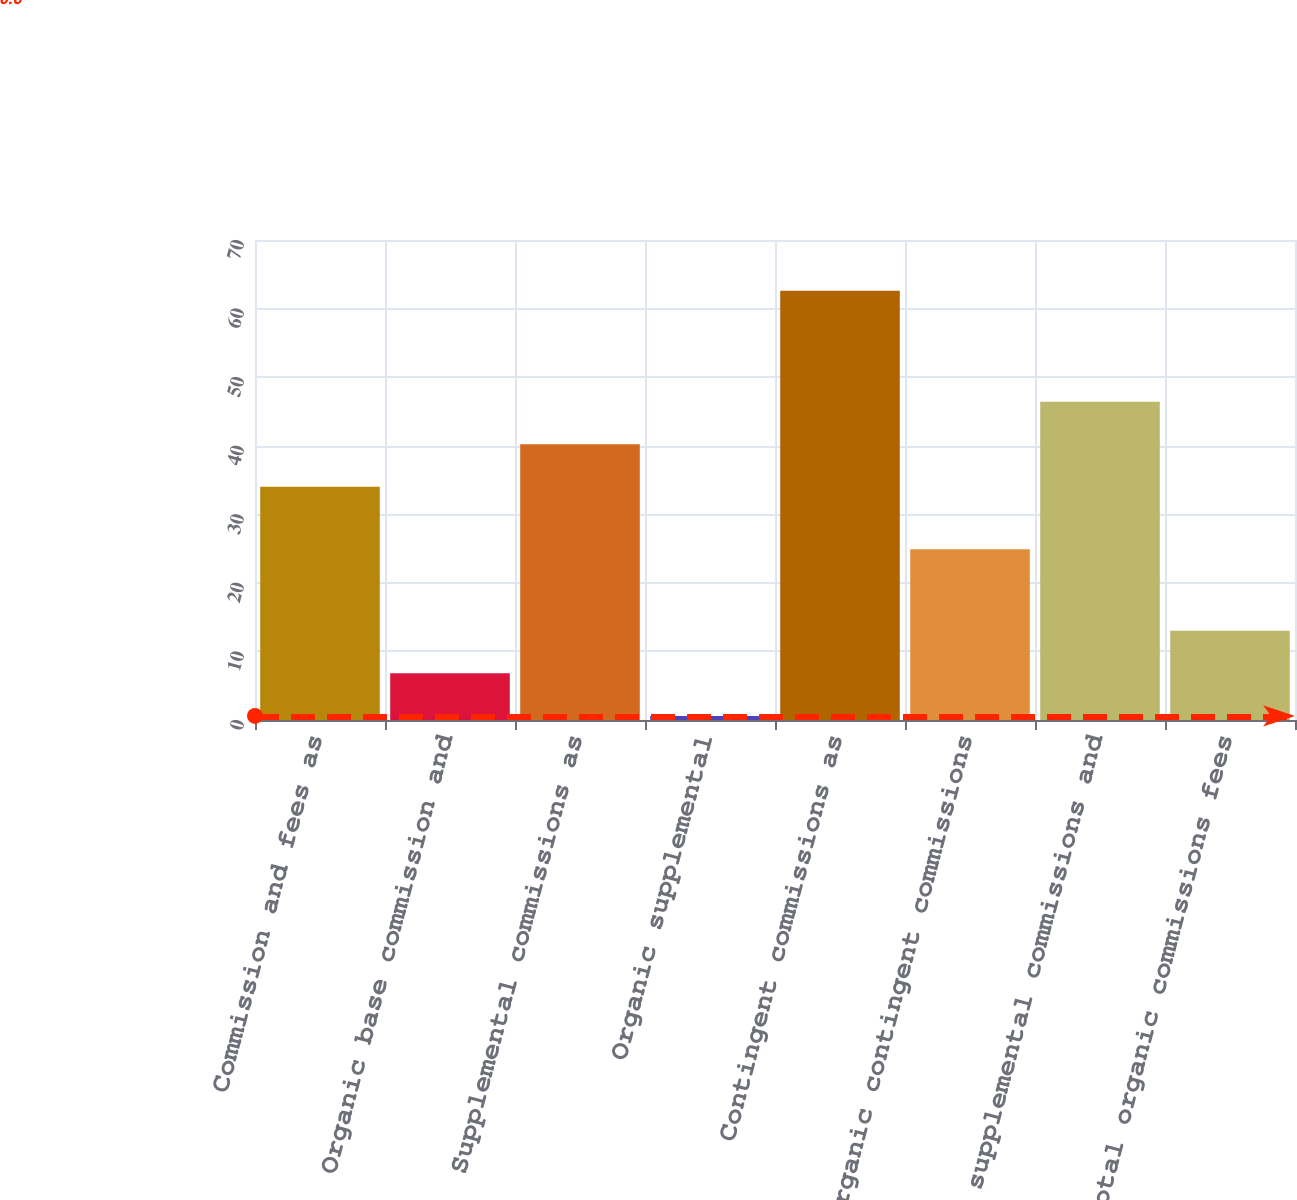Convert chart to OTSL. <chart><loc_0><loc_0><loc_500><loc_500><bar_chart><fcel>Commission and fees as<fcel>Organic base commission and<fcel>Supplemental commissions as<fcel>Organic supplemental<fcel>Contingent commissions as<fcel>Organic contingent commissions<fcel>supplemental commissions and<fcel>Total organic commissions fees<nl><fcel>34<fcel>6.8<fcel>40.2<fcel>0.6<fcel>62.6<fcel>24.9<fcel>46.4<fcel>13<nl></chart> 